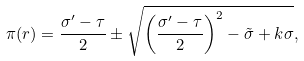Convert formula to latex. <formula><loc_0><loc_0><loc_500><loc_500>\pi ( r ) = \frac { { \sigma } ^ { \prime } - { \tau } } { 2 } \pm \sqrt { \left ( { \frac { { \sigma } ^ { \prime } - { \tau } } { 2 } } \right ) ^ { 2 } - \tilde { \sigma } + k \sigma } ,</formula> 